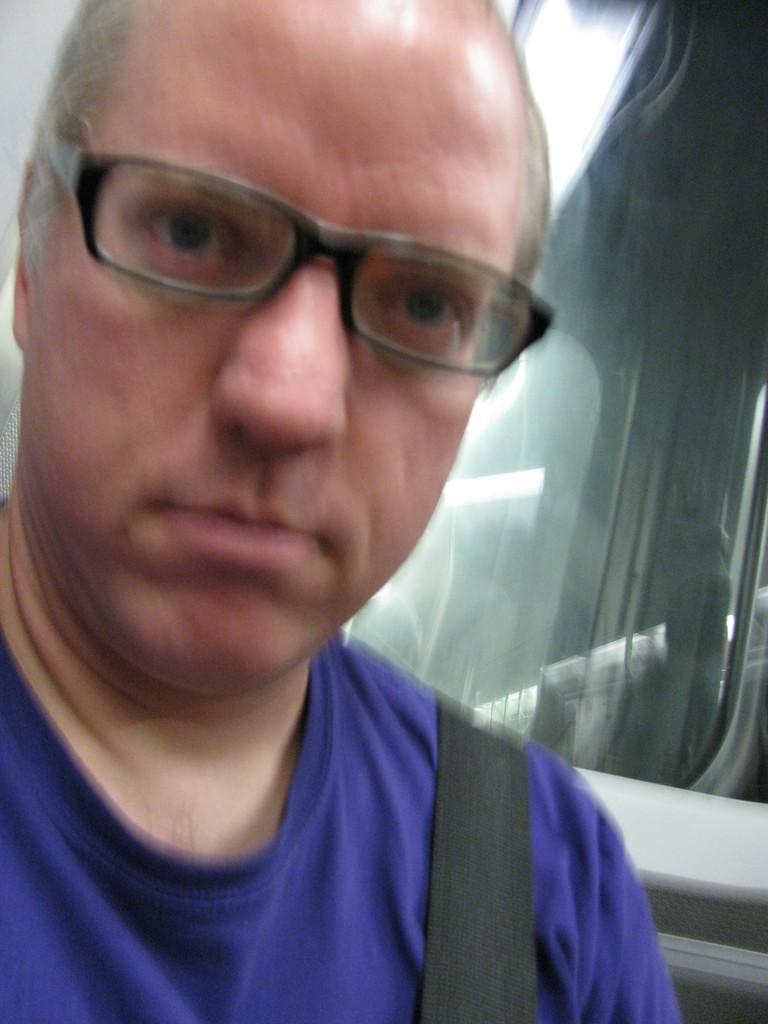Can you describe this image briefly? In this image I can see a man is looking at his side, he wore blue color t-shirt and spectacles. On the right side there is the glass. 